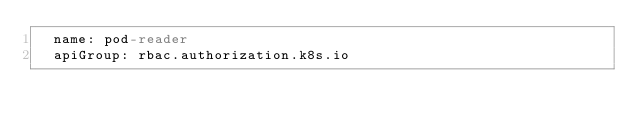Convert code to text. <code><loc_0><loc_0><loc_500><loc_500><_YAML_>  name: pod-reader
  apiGroup: rbac.authorization.k8s.io
</code> 